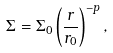<formula> <loc_0><loc_0><loc_500><loc_500>\Sigma = \Sigma _ { 0 } \left ( \frac { r } { r _ { 0 } } \right ) ^ { - p } ,</formula> 